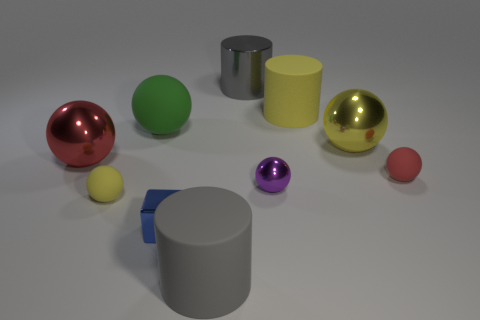Subtract 3 spheres. How many spheres are left? 3 Subtract all purple spheres. How many spheres are left? 5 Subtract all green spheres. How many spheres are left? 5 Subtract all cyan balls. Subtract all blue cubes. How many balls are left? 6 Subtract all spheres. How many objects are left? 4 Subtract all tiny red matte things. Subtract all red matte balls. How many objects are left? 8 Add 6 shiny spheres. How many shiny spheres are left? 9 Add 1 tiny yellow spheres. How many tiny yellow spheres exist? 2 Subtract 0 red cylinders. How many objects are left? 10 